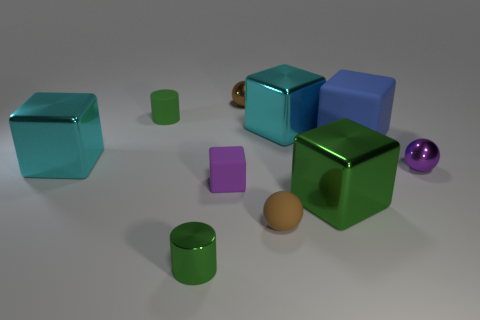Subtract all purple matte cubes. How many cubes are left? 4 Subtract all purple spheres. How many spheres are left? 2 Subtract all spheres. How many objects are left? 7 Subtract all gray blocks. How many brown spheres are left? 2 Subtract all blue spheres. Subtract all green cubes. How many spheres are left? 3 Add 6 small red matte spheres. How many small red matte spheres exist? 6 Subtract 0 yellow cubes. How many objects are left? 10 Subtract 3 cubes. How many cubes are left? 2 Subtract all big rubber cubes. Subtract all brown spheres. How many objects are left? 7 Add 4 tiny brown rubber objects. How many tiny brown rubber objects are left? 5 